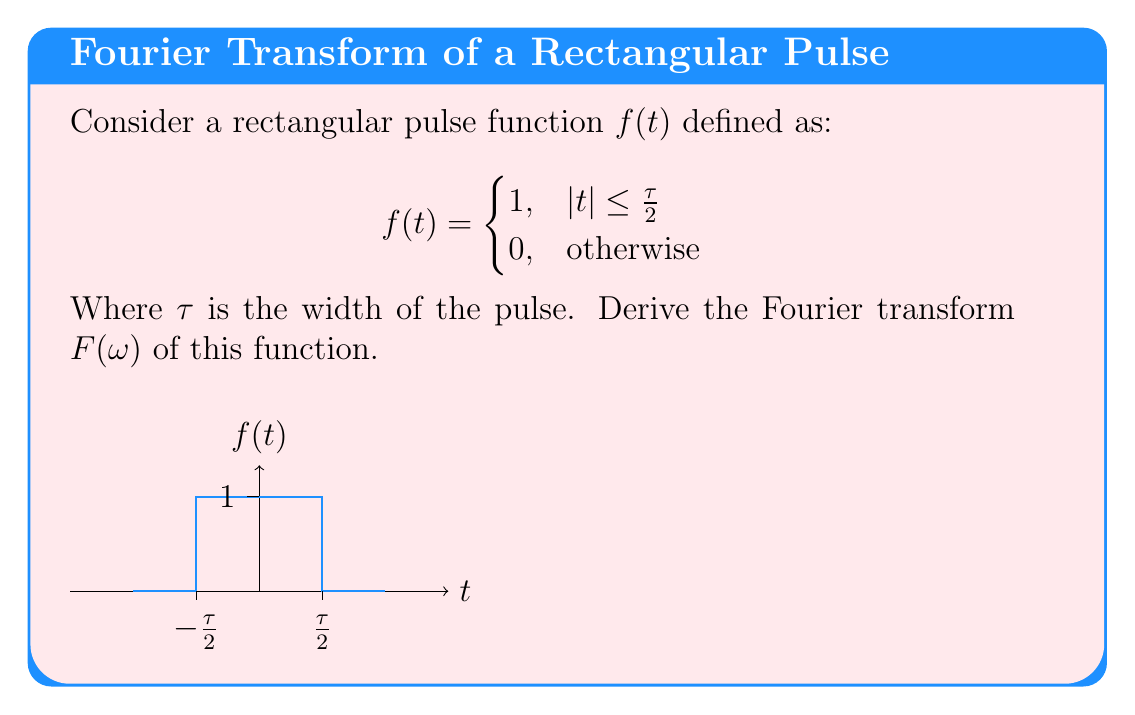Solve this math problem. Let's derive the Fourier transform step-by-step:

1) The Fourier transform is defined as:

   $$F(\omega) = \int_{-\infty}^{\infty} f(t) e^{-i\omega t} dt$$

2) For our rectangular pulse function, we only need to integrate over the non-zero region:

   $$F(\omega) = \int_{-\tau/2}^{\tau/2} e^{-i\omega t} dt$$

3) We can solve this integral:

   $$F(\omega) = \left[-\frac{1}{i\omega} e^{-i\omega t}\right]_{-\tau/2}^{\tau/2}$$

4) Evaluating the bounds:

   $$F(\omega) = -\frac{1}{i\omega} \left(e^{-i\omega \tau/2} - e^{i\omega \tau/2}\right)$$

5) Recall Euler's formula: $e^{ix} - e^{-ix} = 2i\sin(x)$. Applying this:

   $$F(\omega) = -\frac{1}{i\omega} (-2i\sin(\omega \tau/2))$$

6) Simplify:

   $$F(\omega) = \frac{2\sin(\omega \tau/2)}{\omega}$$

7) We can express this in terms of the sinc function:

   $$F(\omega) = \tau \cdot \text{sinc}\left(\frac{\omega \tau}{2}\right)$$

Where $\text{sinc}(x) = \frac{\sin(x)}{x}$.
Answer: $$F(\omega) = \tau \cdot \text{sinc}\left(\frac{\omega \tau}{2}\right)$$ 